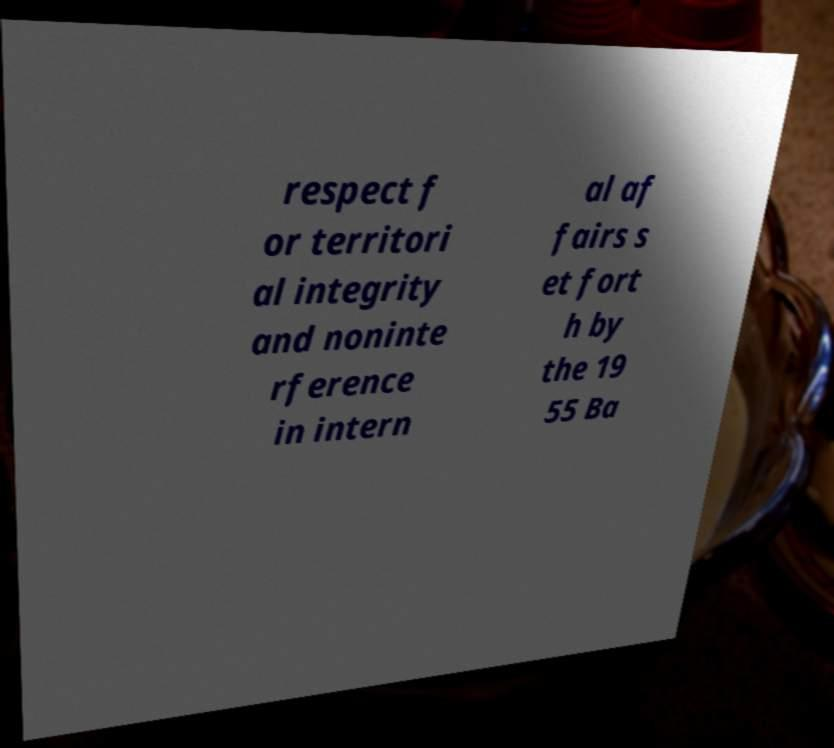Can you read and provide the text displayed in the image?This photo seems to have some interesting text. Can you extract and type it out for me? respect f or territori al integrity and noninte rference in intern al af fairs s et fort h by the 19 55 Ba 